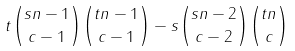Convert formula to latex. <formula><loc_0><loc_0><loc_500><loc_500>t \binom { s n - 1 } { c - 1 } \binom { t n - 1 } { c - 1 } - s \binom { s n - 2 } { c - 2 } \binom { t n } { c }</formula> 